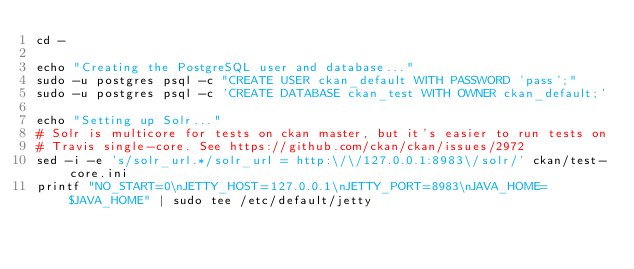Convert code to text. <code><loc_0><loc_0><loc_500><loc_500><_Bash_>cd -

echo "Creating the PostgreSQL user and database..."
sudo -u postgres psql -c "CREATE USER ckan_default WITH PASSWORD 'pass';"
sudo -u postgres psql -c 'CREATE DATABASE ckan_test WITH OWNER ckan_default;'

echo "Setting up Solr..."
# Solr is multicore for tests on ckan master, but it's easier to run tests on
# Travis single-core. See https://github.com/ckan/ckan/issues/2972
sed -i -e 's/solr_url.*/solr_url = http:\/\/127.0.0.1:8983\/solr/' ckan/test-core.ini
printf "NO_START=0\nJETTY_HOST=127.0.0.1\nJETTY_PORT=8983\nJAVA_HOME=$JAVA_HOME" | sudo tee /etc/default/jetty</code> 